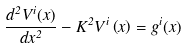Convert formula to latex. <formula><loc_0><loc_0><loc_500><loc_500>\frac { d ^ { 2 } V ^ { i } ( x ) } { d x ^ { 2 } } - K ^ { 2 } V ^ { i } \left ( x \right ) = g ^ { i } ( x )</formula> 